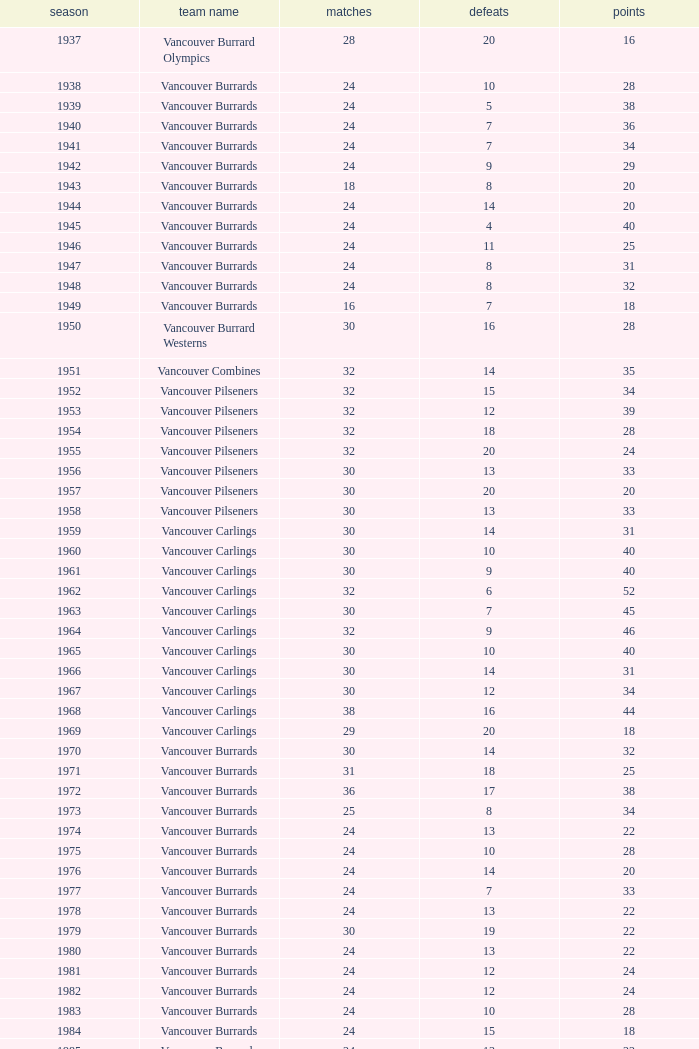What's the total number of points when the vancouver burrards have fewer than 9 losses and more than 24 games? 1.0. 